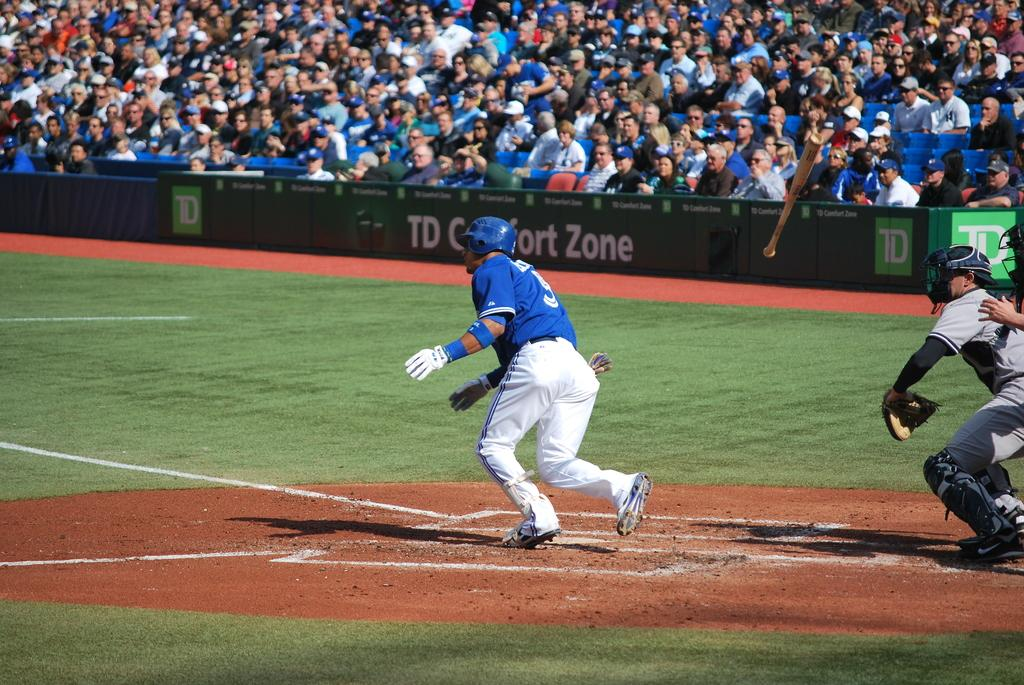<image>
Describe the image concisely. Player number 5 heads towards first base if record a hit in a baseball game. 